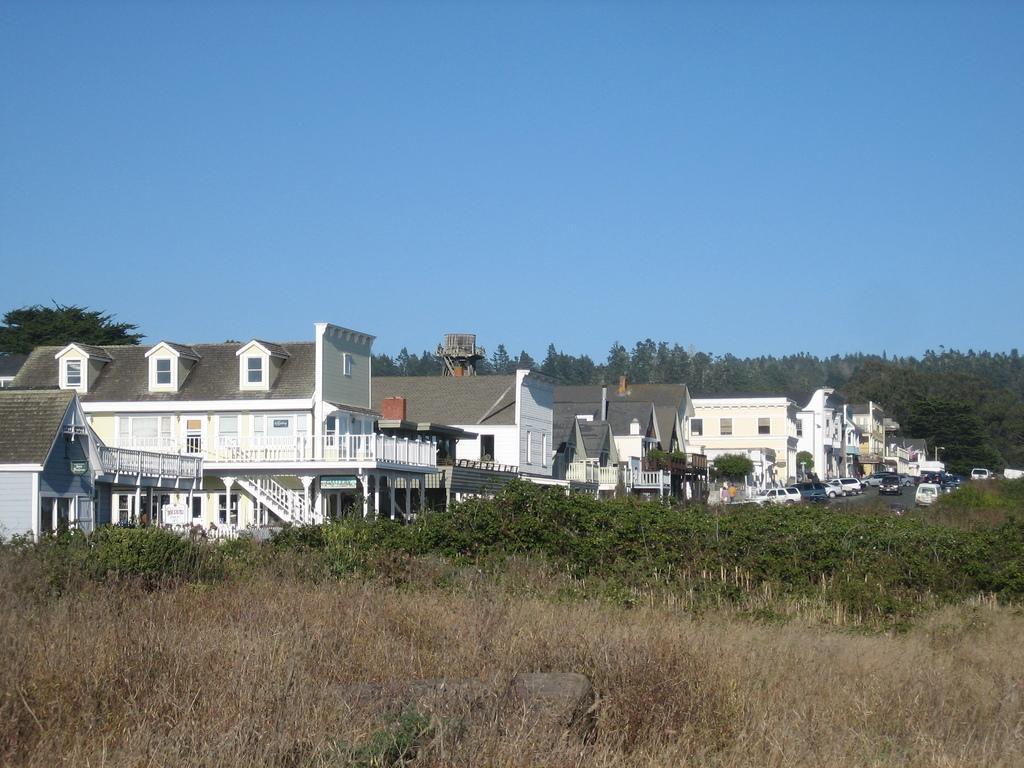Please provide a concise description of this image. In this image we can see many trees and plants. There are many houses in the image. There are many vehicles in the image. We can see the sky in the image. 